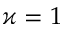Convert formula to latex. <formula><loc_0><loc_0><loc_500><loc_500>\varkappa = 1</formula> 